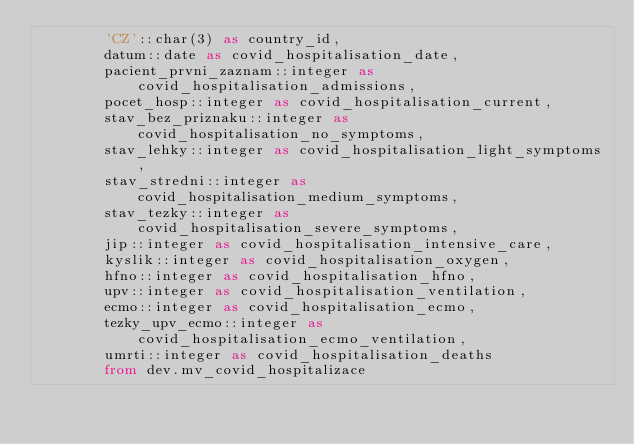Convert code to text. <code><loc_0><loc_0><loc_500><loc_500><_SQL_>        'CZ'::char(3) as country_id,
        datum::date as covid_hospitalisation_date, 
		pacient_prvni_zaznam::integer as covid_hospitalisation_admissions,
        pocet_hosp::integer as covid_hospitalisation_current,
        stav_bez_priznaku::integer as covid_hospitalisation_no_symptoms,
        stav_lehky::integer as covid_hospitalisation_light_symptoms,
        stav_stredni::integer as covid_hospitalisation_medium_symptoms,
        stav_tezky::integer as covid_hospitalisation_severe_symptoms,
        jip::integer as covid_hospitalisation_intensive_care,
		kyslik::integer as covid_hospitalisation_oxygen,
        hfno::integer as covid_hospitalisation_hfno,
        upv::integer as covid_hospitalisation_ventilation,
        ecmo::integer as covid_hospitalisation_ecmo,
        tezky_upv_ecmo::integer as covid_hospitalisation_ecmo_ventilation,
        umrti::integer as covid_hospitalisation_deaths
		from dev.mv_covid_hospitalizace</code> 